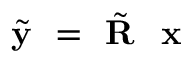Convert formula to latex. <formula><loc_0><loc_0><loc_500><loc_500>\tilde { y } = \tilde { R } x</formula> 